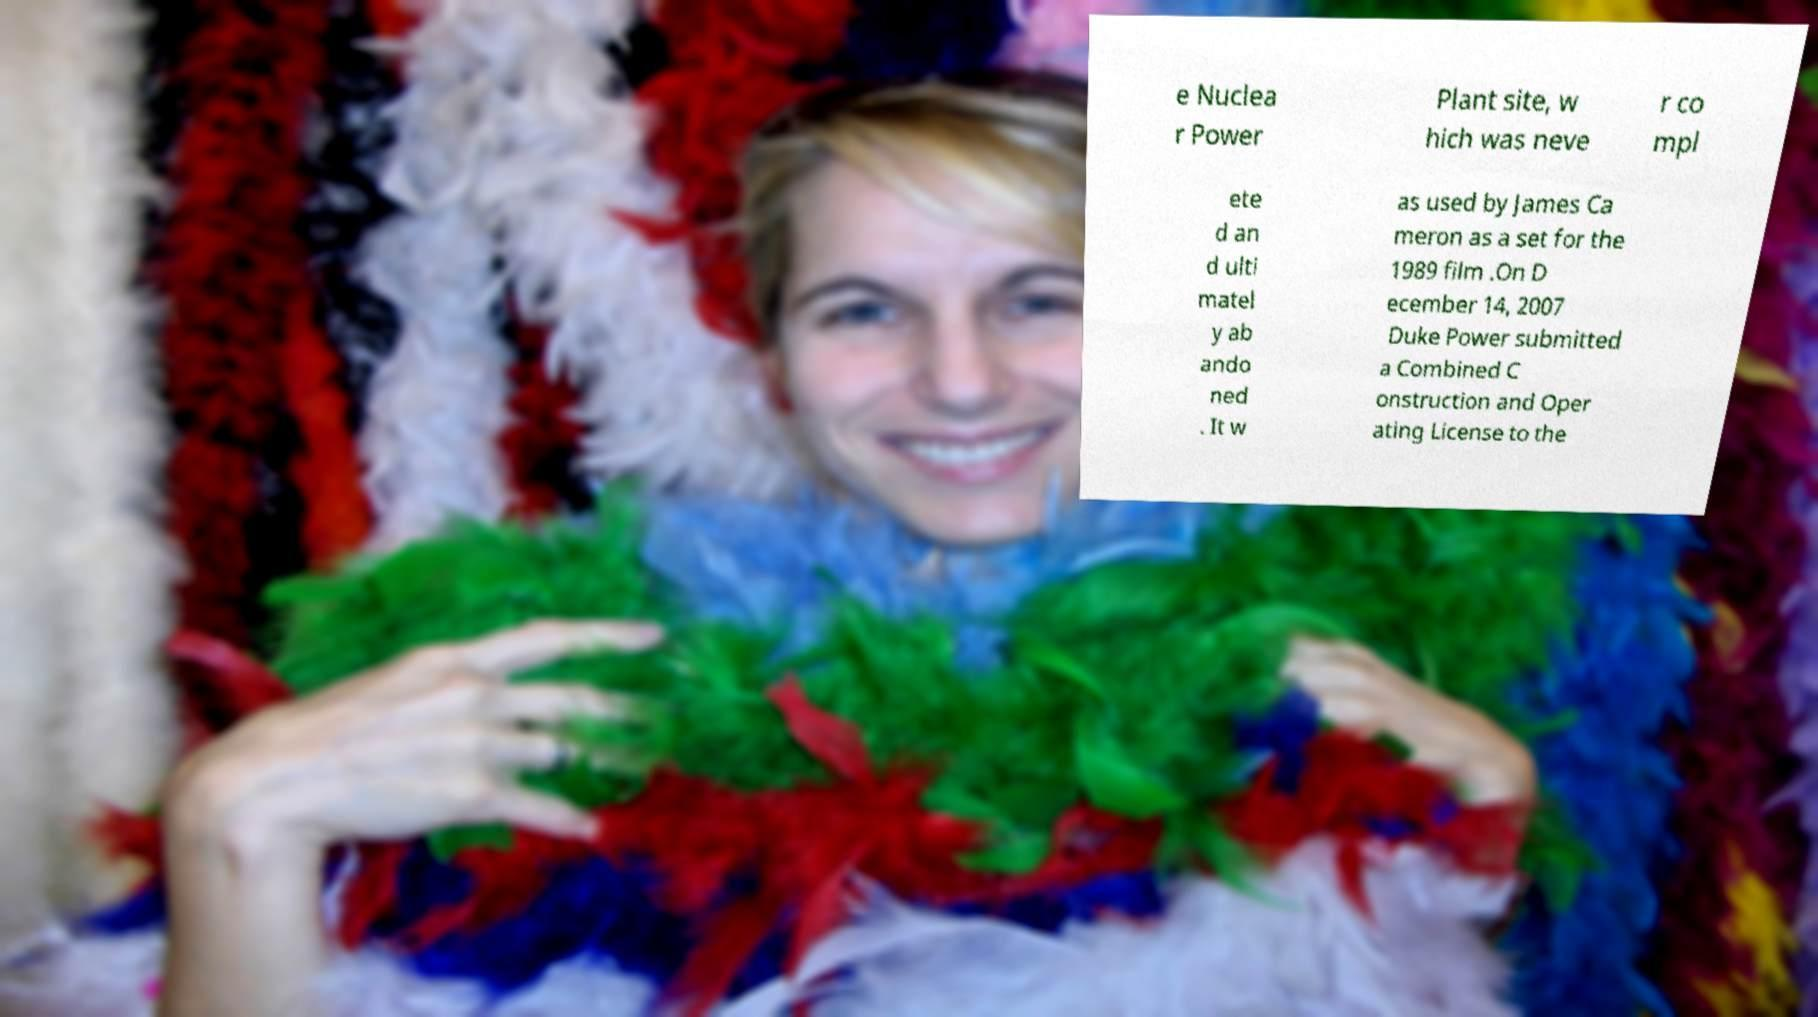I need the written content from this picture converted into text. Can you do that? e Nuclea r Power Plant site, w hich was neve r co mpl ete d an d ulti matel y ab ando ned . It w as used by James Ca meron as a set for the 1989 film .On D ecember 14, 2007 Duke Power submitted a Combined C onstruction and Oper ating License to the 